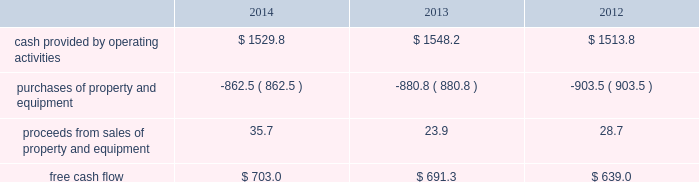Financial assurance we must provide financial assurance to governmental agencies and a variety of other entities under applicable environmental regulations relating to our landfill operations for capping , closure and post-closure costs , and related to our performance under certain collection , landfill and transfer station contracts .
We satisfy these financial assurance requirements by providing surety bonds , letters of credit , or insurance policies ( financial assurance instruments ) , or trust deposits , which are included in restricted cash and marketable securities and other assets in our consolidated balance sheets .
The amount of the financial assurance requirements for capping , closure and post-closure costs is determined by applicable state environmental regulations .
The financial assurance requirements for capping , closure and post-closure costs may be associated with a portion of the landfill or the entire landfill .
Generally , states require a third-party engineering specialist to determine the estimated capping , closure and post-closure costs that are used to determine the required amount of financial assurance for a landfill .
The amount of financial assurance required can , and generally will , differ from the obligation determined and recorded under u.s .
Gaap .
The amount of the financial assurance requirements related to contract performance varies by contract .
Additionally , we must provide financial assurance for our insurance program and collateral for certain performance obligations .
We do not expect a material increase in financial assurance requirements during 2015 , although the mix of financial assurance instruments may change .
These financial assurance instruments are issued in the normal course of business and are not considered indebtedness .
Because we currently have no liability for the financial assurance instruments , they are not reflected in our consolidated balance sheets ; however , we record capping , closure and post-closure liabilities and insurance liabilities as they are incurred .
The underlying obligations of the financial assurance instruments , in excess of those already reflected in our consolidated balance sheets , would be recorded if it is probable that we would be unable to fulfill our related obligations .
We do not expect this to occur .
Off-balance sheet arrangements we have no off-balance sheet debt or similar obligations , other than operating leases and financial assurances , which are not classified as debt .
We have no transactions or obligations with related parties that are not disclosed , consolidated into or reflected in our reported financial position or results of operations .
We have not guaranteed any third-party debt .
Free cash flow we define free cash flow , which is not a measure determined in accordance with u.s .
Gaap , as cash provided by operating activities less purchases of property and equipment , plus proceeds from sales of property and equipment , as presented in our consolidated statements of cash flows .
The table calculates our free cash flow for the years ended december 31 , 2014 , 2013 and 2012 ( in millions of dollars ) : .
For a discussion of the changes in the components of free cash flow , you should read our discussion regarding cash flows provided by operating activities and cash flows used in investing activities contained elsewhere in this management 2019s discussion and analysis of financial condition and results of operations. .
In 2014 what was the ratio of the cash provided by operating activities to the free cash flow? 
Rationale: every two dollars of cash provided by operating activities led to $ 1 of free cash flow
Computations: (1529.8 / 703.0)
Answer: 2.1761. 